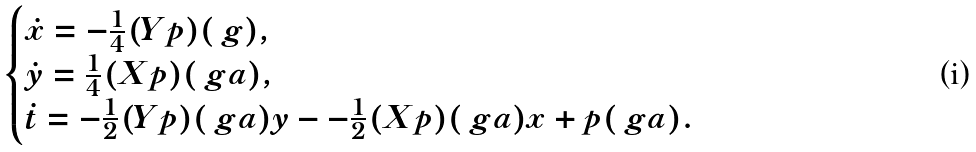Convert formula to latex. <formula><loc_0><loc_0><loc_500><loc_500>\begin{cases} \dot { x } = - \frac { 1 } { 4 } ( Y p ) ( \ g ) , & \\ \dot { y } = \frac { 1 } { 4 } ( X p ) ( \ g a ) , & \\ \dot { t } = - \frac { 1 } { 2 } ( Y p ) ( \ g a ) y - - \frac { 1 } { 2 } ( X p ) ( \ g a ) x + p ( \ g a ) . & \end{cases}</formula> 